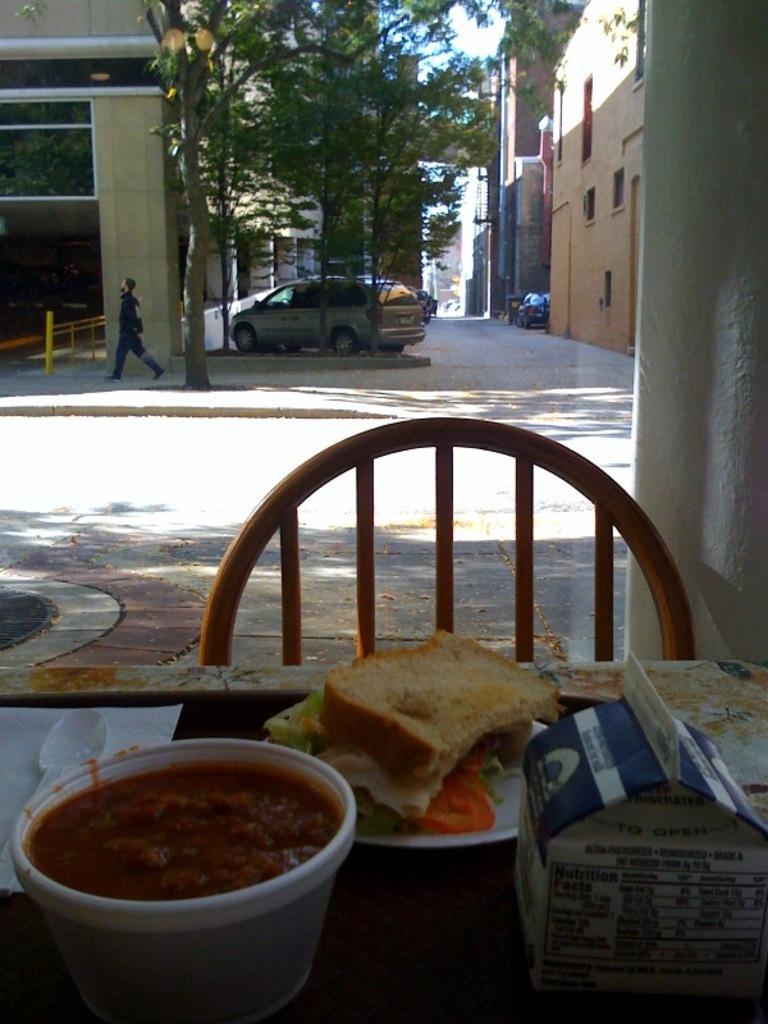How would you summarize this image in a sentence or two? In this picture we can see some food, spoon, bread and a box on the table, in the background a man is walking and we can see couple of buildings, trees and cars. 